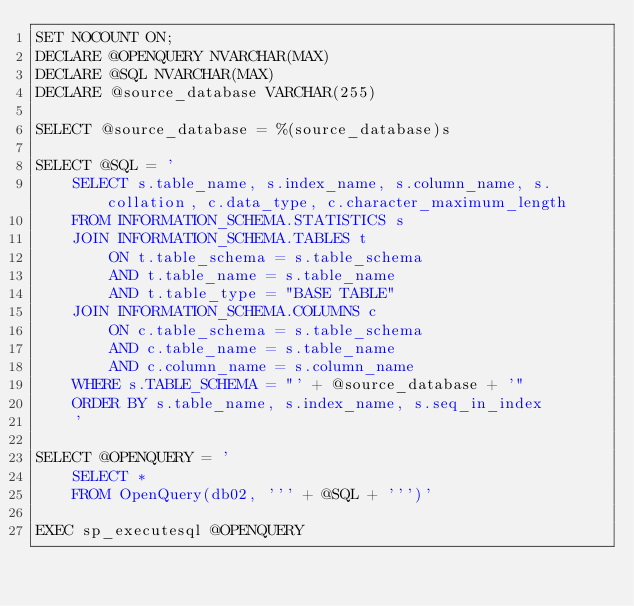<code> <loc_0><loc_0><loc_500><loc_500><_SQL_>SET NOCOUNT ON;
DECLARE @OPENQUERY NVARCHAR(MAX)
DECLARE @SQL NVARCHAR(MAX)
DECLARE @source_database VARCHAR(255)

SELECT @source_database = %(source_database)s

SELECT @SQL = '
    SELECT s.table_name, s.index_name, s.column_name, s.collation, c.data_type, c.character_maximum_length
    FROM INFORMATION_SCHEMA.STATISTICS s
    JOIN INFORMATION_SCHEMA.TABLES t
        ON t.table_schema = s.table_schema
        AND t.table_name = s.table_name
        AND t.table_type = "BASE TABLE"
    JOIN INFORMATION_SCHEMA.COLUMNS c
        ON c.table_schema = s.table_schema
        AND c.table_name = s.table_name
        AND c.column_name = s.column_name
    WHERE s.TABLE_SCHEMA = "' + @source_database + '"
    ORDER BY s.table_name, s.index_name, s.seq_in_index
    '

SELECT @OPENQUERY = '
    SELECT *
    FROM OpenQuery(db02, ''' + @SQL + ''')'

EXEC sp_executesql @OPENQUERY
</code> 